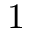Convert formula to latex. <formula><loc_0><loc_0><loc_500><loc_500>1</formula> 